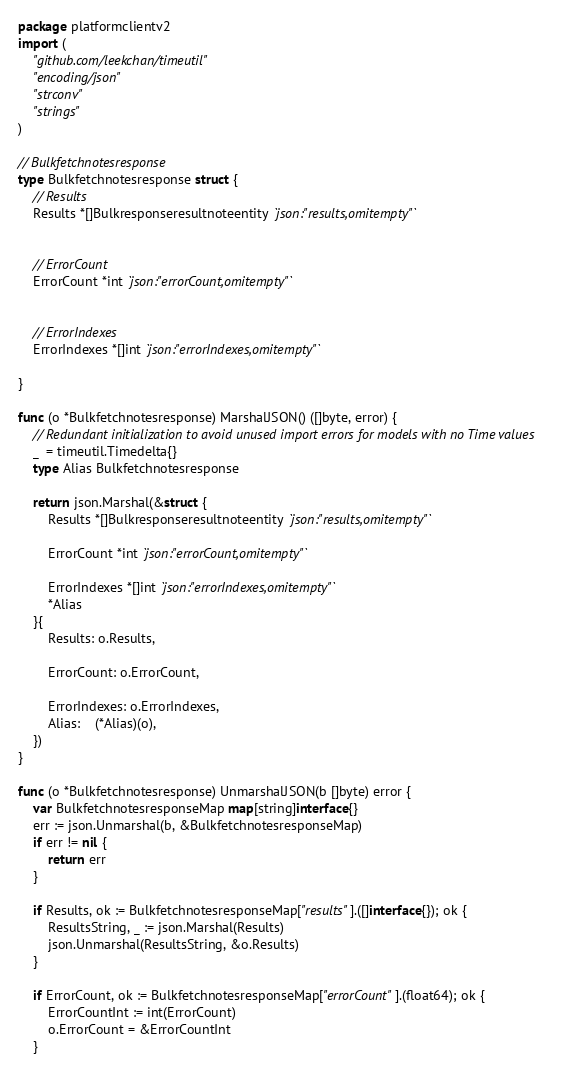<code> <loc_0><loc_0><loc_500><loc_500><_Go_>package platformclientv2
import (
	"github.com/leekchan/timeutil"
	"encoding/json"
	"strconv"
	"strings"
)

// Bulkfetchnotesresponse
type Bulkfetchnotesresponse struct { 
	// Results
	Results *[]Bulkresponseresultnoteentity `json:"results,omitempty"`


	// ErrorCount
	ErrorCount *int `json:"errorCount,omitempty"`


	// ErrorIndexes
	ErrorIndexes *[]int `json:"errorIndexes,omitempty"`

}

func (o *Bulkfetchnotesresponse) MarshalJSON() ([]byte, error) {
	// Redundant initialization to avoid unused import errors for models with no Time values
	_  = timeutil.Timedelta{}
	type Alias Bulkfetchnotesresponse
	
	return json.Marshal(&struct { 
		Results *[]Bulkresponseresultnoteentity `json:"results,omitempty"`
		
		ErrorCount *int `json:"errorCount,omitempty"`
		
		ErrorIndexes *[]int `json:"errorIndexes,omitempty"`
		*Alias
	}{ 
		Results: o.Results,
		
		ErrorCount: o.ErrorCount,
		
		ErrorIndexes: o.ErrorIndexes,
		Alias:    (*Alias)(o),
	})
}

func (o *Bulkfetchnotesresponse) UnmarshalJSON(b []byte) error {
	var BulkfetchnotesresponseMap map[string]interface{}
	err := json.Unmarshal(b, &BulkfetchnotesresponseMap)
	if err != nil {
		return err
	}
	
	if Results, ok := BulkfetchnotesresponseMap["results"].([]interface{}); ok {
		ResultsString, _ := json.Marshal(Results)
		json.Unmarshal(ResultsString, &o.Results)
	}
	
	if ErrorCount, ok := BulkfetchnotesresponseMap["errorCount"].(float64); ok {
		ErrorCountInt := int(ErrorCount)
		o.ErrorCount = &ErrorCountInt
	}
	</code> 